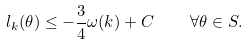Convert formula to latex. <formula><loc_0><loc_0><loc_500><loc_500>l _ { k } ( \theta ) \leq - \frac { 3 } { 4 } \omega ( k ) + C \quad \forall \theta \in S .</formula> 